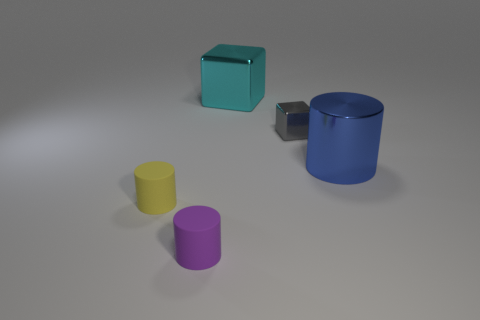There is a large cylinder in front of the large cyan thing; what is its material?
Provide a short and direct response. Metal. What number of tiny purple cylinders are made of the same material as the cyan cube?
Offer a very short reply. 0. There is a object that is on the right side of the big cyan shiny object and behind the big blue metallic cylinder; what shape is it?
Make the answer very short. Cube. How many objects are either cubes to the left of the gray thing or cylinders that are on the left side of the cyan cube?
Your answer should be very brief. 3. Is the number of blue cylinders left of the gray cube the same as the number of gray metal cubes in front of the cyan thing?
Ensure brevity in your answer.  No. There is a large shiny object behind the shiny object in front of the small shiny block; what is its shape?
Keep it short and to the point. Cube. Are there any other tiny purple matte objects of the same shape as the small purple matte thing?
Make the answer very short. No. What number of shiny cylinders are there?
Provide a short and direct response. 1. Are the block on the right side of the cyan object and the purple object made of the same material?
Keep it short and to the point. No. Is there a block of the same size as the gray thing?
Provide a short and direct response. No. 